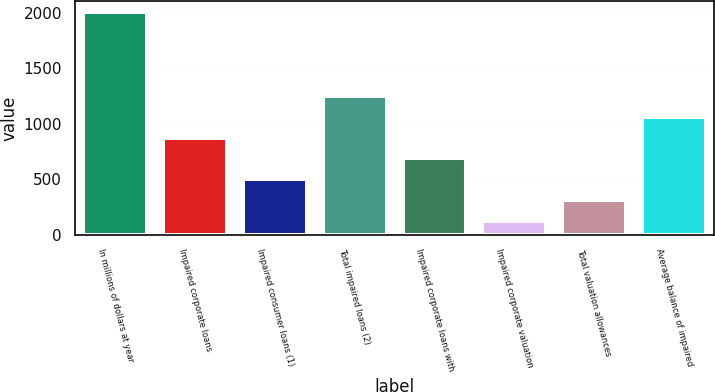<chart> <loc_0><loc_0><loc_500><loc_500><bar_chart><fcel>In millions of dollars at year<fcel>Impaired corporate loans<fcel>Impaired consumer loans (1)<fcel>Total impaired loans (2)<fcel>Impaired corporate loans with<fcel>Impaired corporate valuation<fcel>Total valuation allowances<fcel>Average balance of impaired<nl><fcel>2006<fcel>875.6<fcel>498.8<fcel>1252.4<fcel>687.2<fcel>122<fcel>310.4<fcel>1064<nl></chart> 